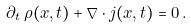Convert formula to latex. <formula><loc_0><loc_0><loc_500><loc_500>\partial _ { t } \, \rho ( x , t ) + \nabla \cdot j ( x , t ) = 0 \, .</formula> 